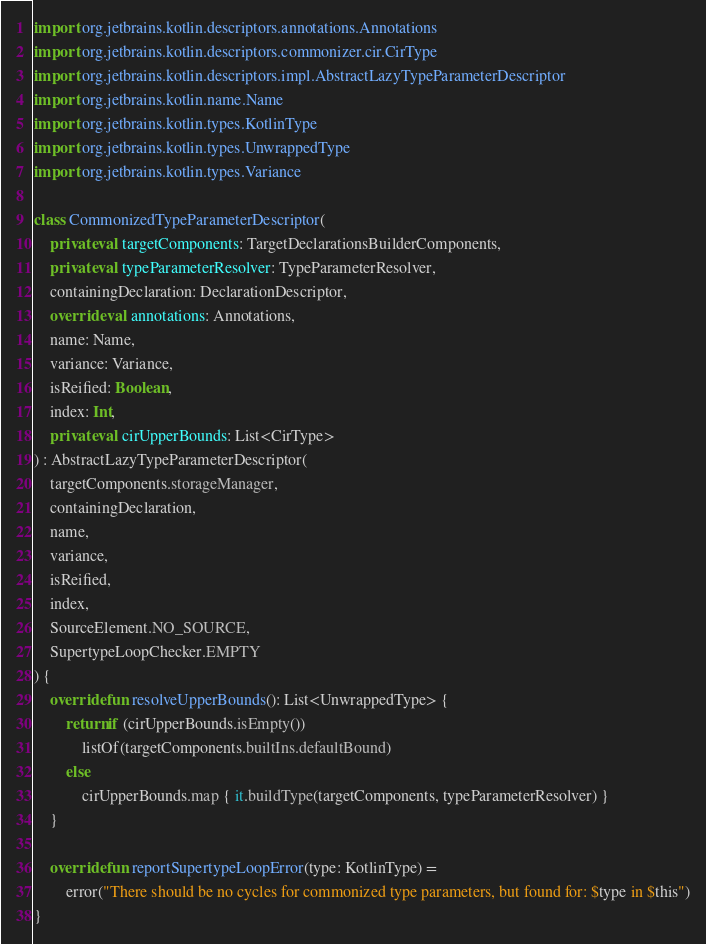<code> <loc_0><loc_0><loc_500><loc_500><_Kotlin_>import org.jetbrains.kotlin.descriptors.annotations.Annotations
import org.jetbrains.kotlin.descriptors.commonizer.cir.CirType
import org.jetbrains.kotlin.descriptors.impl.AbstractLazyTypeParameterDescriptor
import org.jetbrains.kotlin.name.Name
import org.jetbrains.kotlin.types.KotlinType
import org.jetbrains.kotlin.types.UnwrappedType
import org.jetbrains.kotlin.types.Variance

class CommonizedTypeParameterDescriptor(
    private val targetComponents: TargetDeclarationsBuilderComponents,
    private val typeParameterResolver: TypeParameterResolver,
    containingDeclaration: DeclarationDescriptor,
    override val annotations: Annotations,
    name: Name,
    variance: Variance,
    isReified: Boolean,
    index: Int,
    private val cirUpperBounds: List<CirType>
) : AbstractLazyTypeParameterDescriptor(
    targetComponents.storageManager,
    containingDeclaration,
    name,
    variance,
    isReified,
    index,
    SourceElement.NO_SOURCE,
    SupertypeLoopChecker.EMPTY
) {
    override fun resolveUpperBounds(): List<UnwrappedType> {
        return if (cirUpperBounds.isEmpty())
            listOf(targetComponents.builtIns.defaultBound)
        else
            cirUpperBounds.map { it.buildType(targetComponents, typeParameterResolver) }
    }

    override fun reportSupertypeLoopError(type: KotlinType) =
        error("There should be no cycles for commonized type parameters, but found for: $type in $this")
}
</code> 